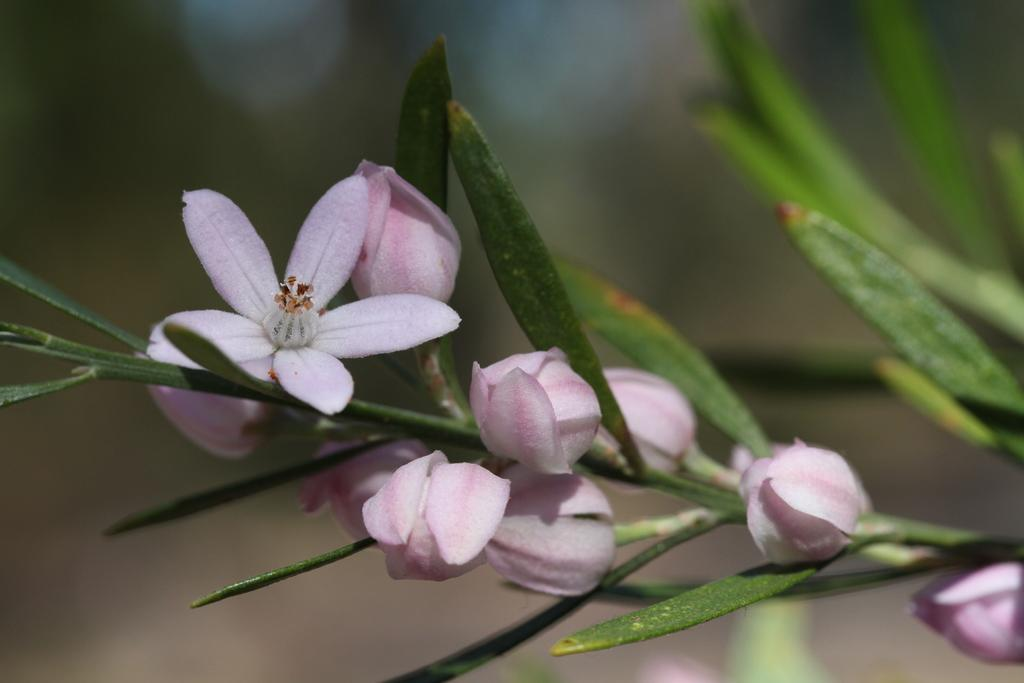What type of living organisms can be seen in the image? There are flowers in the image. How are the flowers connected to the plant? The flowers are attached to a plant. What color are the leaves of the plant? The leaves of the plant are green. Can you describe the background of the image? The background of the image is blurred. What type of quiver is visible in the image? There is no quiver present in the image. How does the design of the plant contribute to the overall aesthetic of the image? The image does not focus on the design of the plant, but rather on the flowers and their colors. 